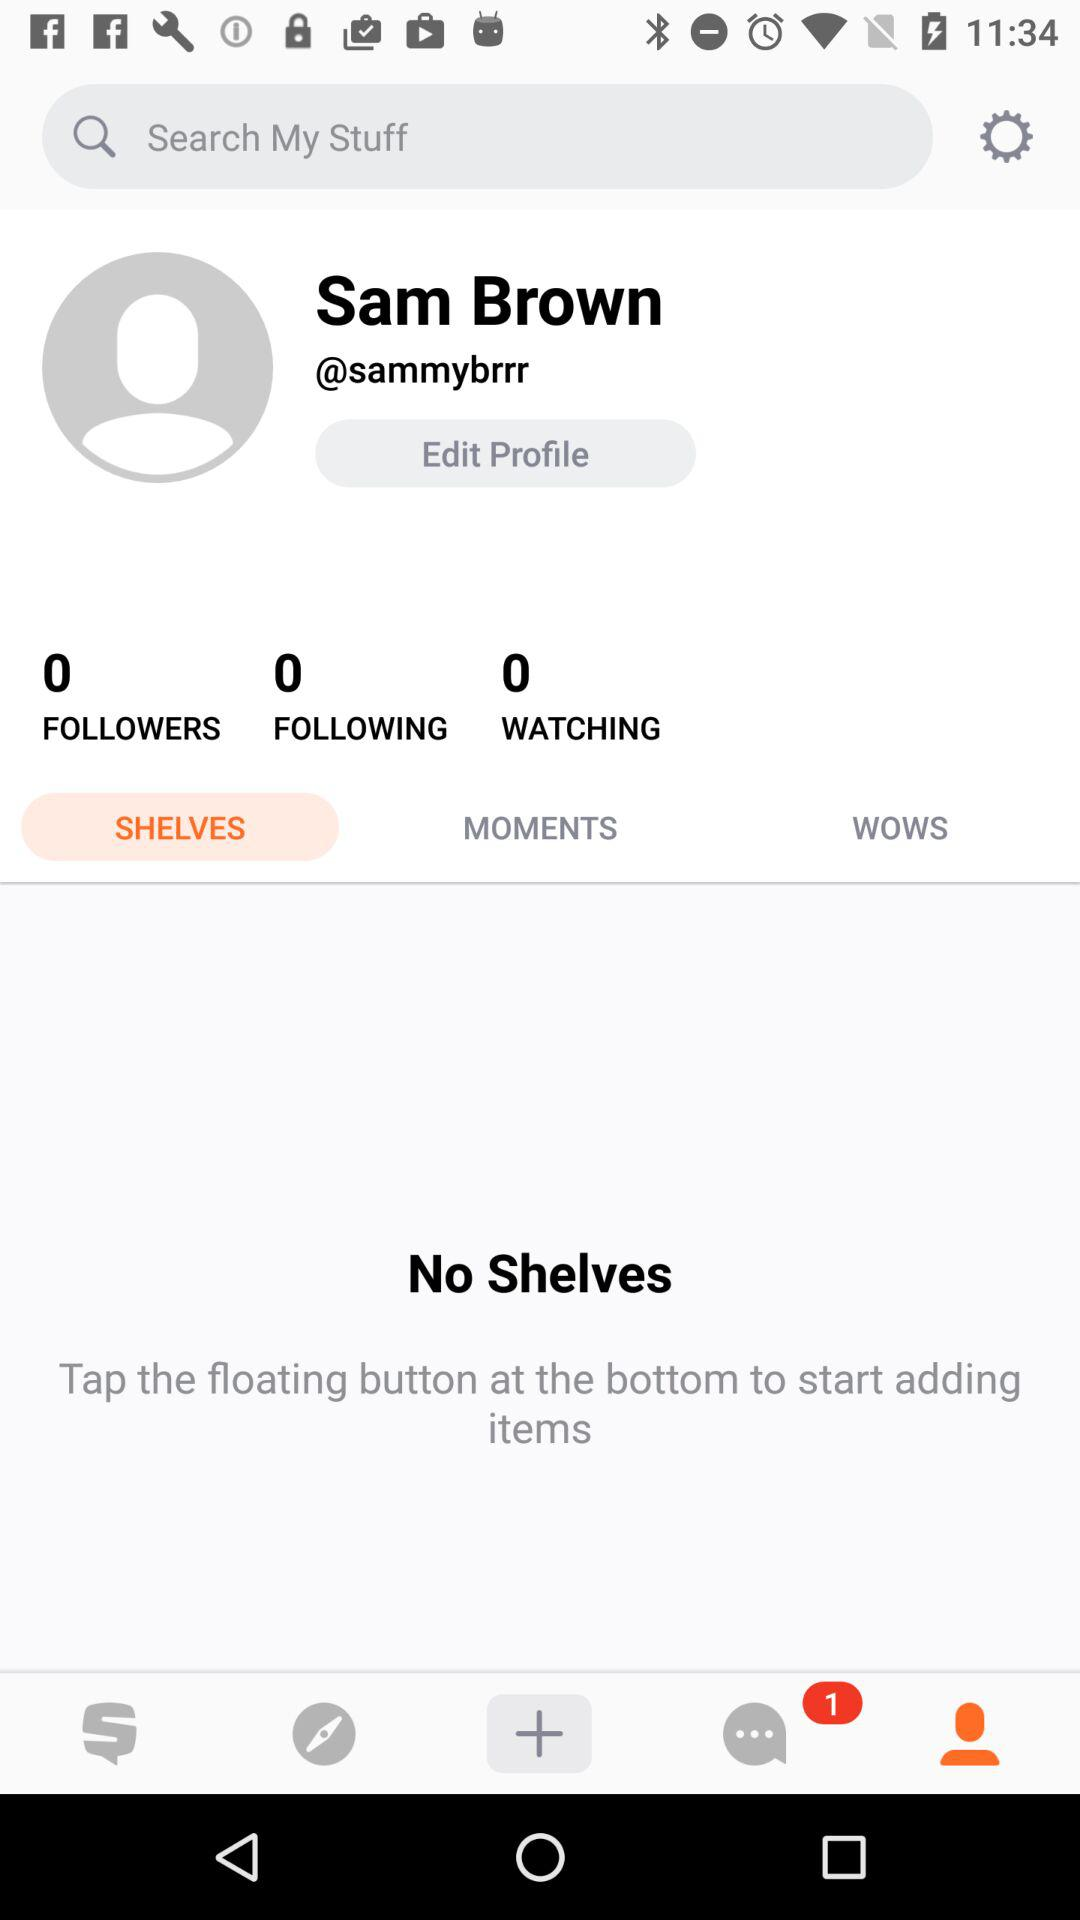How many unread messages are pending on chat? There is 1 unread message pending in chat. 